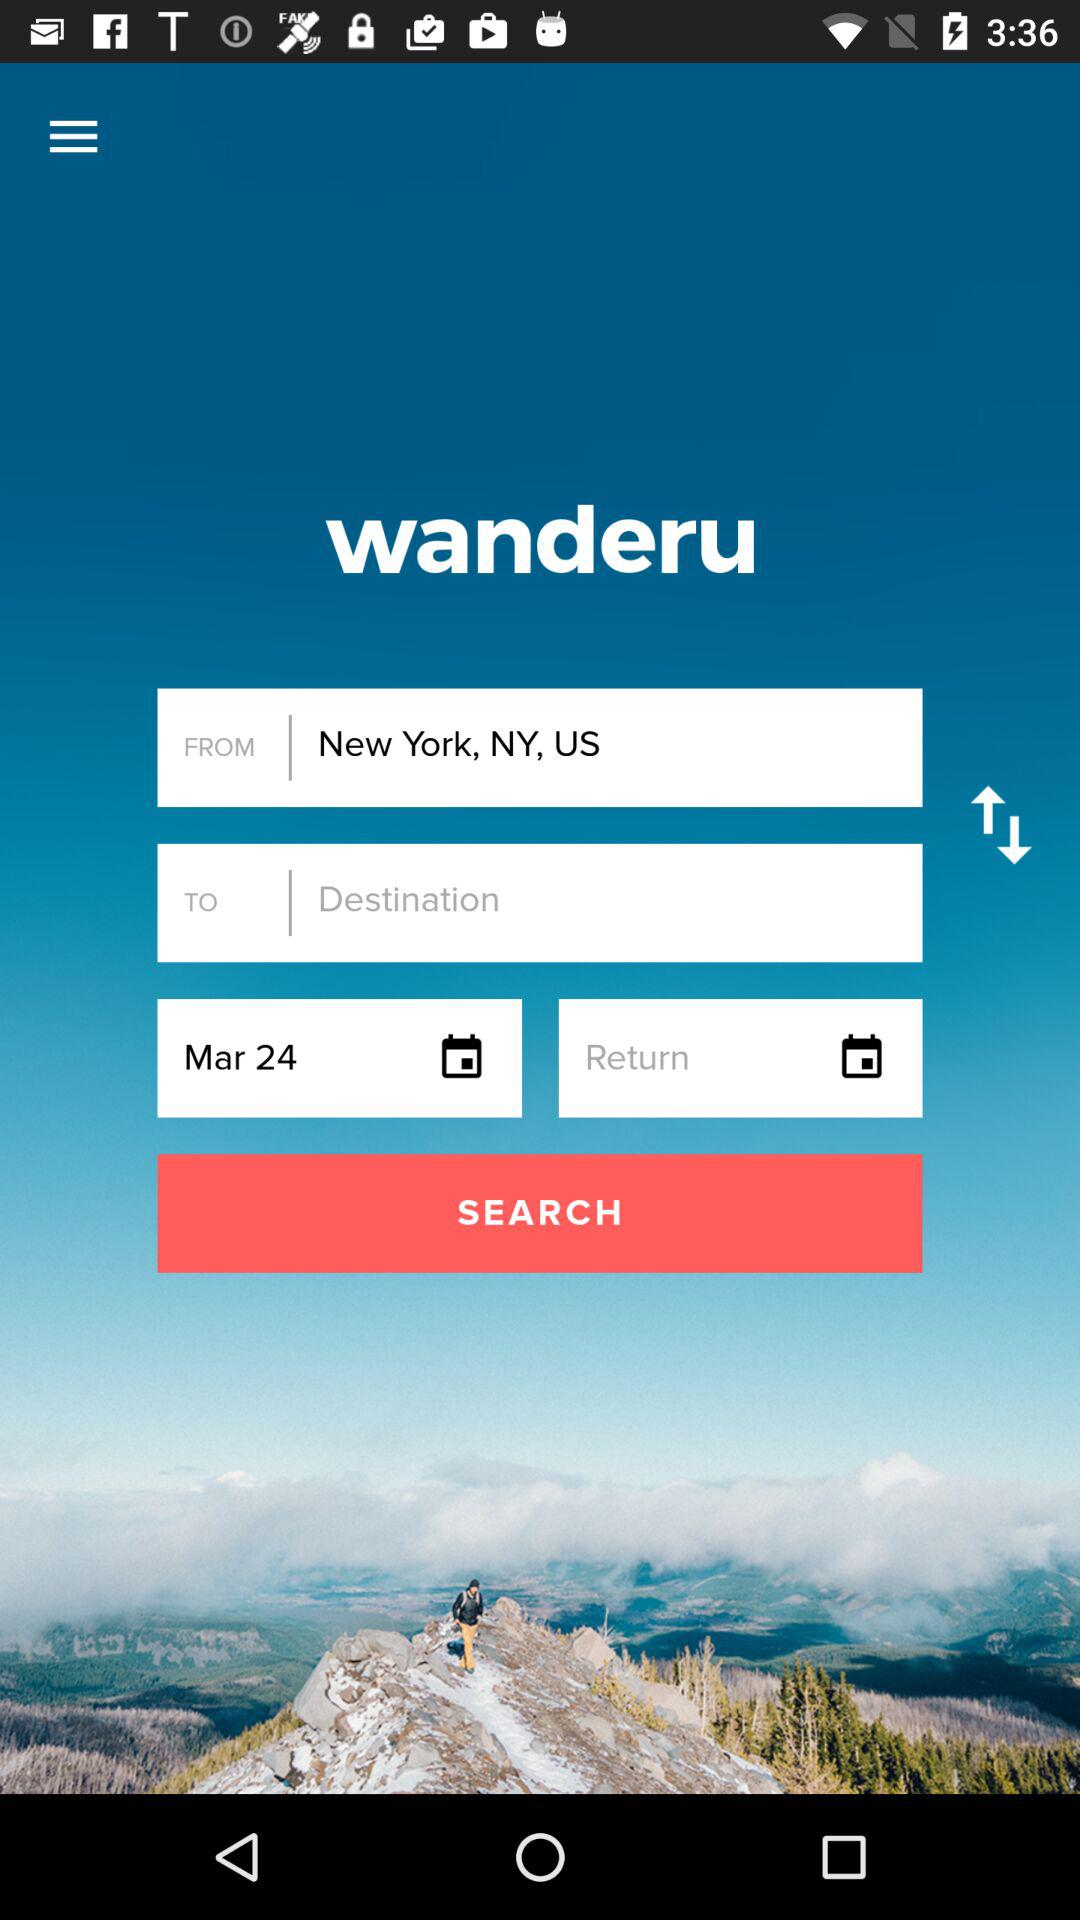What is the departure location? The departure location is New York, NY, US. 